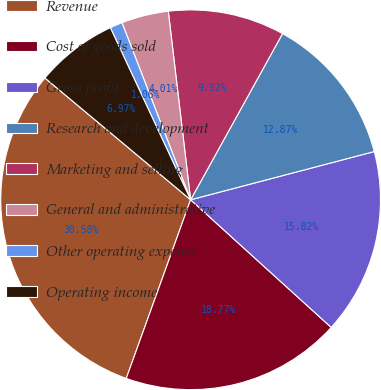Convert chart to OTSL. <chart><loc_0><loc_0><loc_500><loc_500><pie_chart><fcel>Revenue<fcel>Cost of goods sold<fcel>Gross profit<fcel>Research and development<fcel>Marketing and selling<fcel>General and administrative<fcel>Other operating expense<fcel>Operating income<nl><fcel>30.58%<fcel>18.77%<fcel>15.82%<fcel>12.87%<fcel>9.92%<fcel>4.01%<fcel>1.06%<fcel>6.97%<nl></chart> 